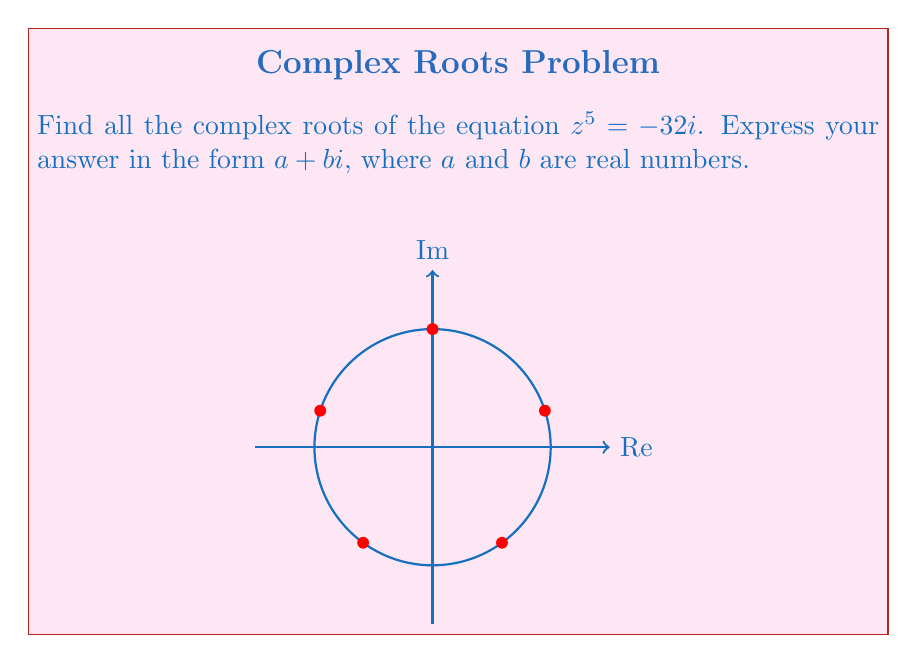Show me your answer to this math problem. Let's solve this step-by-step using De Moivre's theorem:

1) First, we need to express $-32i$ in polar form:
   $-32i = 32(\cos(\frac{3\pi}{2}) + i\sin(\frac{3\pi}{2}))$

2) Now, we can write the equation as:
   $z^5 = 32(\cos(\frac{3\pi}{2}) + i\sin(\frac{3\pi}{2}))$

3) Using De Moivre's theorem, we can write the general solution as:
   $z = 2(\cos(\frac{3\pi + 4k\pi}{10}) + i\sin(\frac{3\pi + 4k\pi}{10}))$
   where $k = 0, 1, 2, 3, 4$

4) Now, let's calculate each root:

   For $k = 0$:
   $z_1 = 2(\cos(\frac{3\pi}{10}) + i\sin(\frac{3\pi}{10}))$
   $= 2(\cos(54°) + i\sin(54°))$
   $\approx 1.18 + 1.62i$

   For $k = 1$:
   $z_2 = 2(\cos(\frac{7\pi}{10}) + i\sin(\frac{7\pi}{10}))$
   $= 2(\cos(126°) + i\sin(126°))$
   $\approx -1.18 + 1.62i$

   For $k = 2$:
   $z_3 = 2(\cos(\frac{11\pi}{10}) + i\sin(\frac{11\pi}{10}))$
   $= 2(\cos(198°) + i\sin(198°))$
   $\approx -1.90 - 0.62i$

   For $k = 3$:
   $z_4 = 2(\cos(\frac{15\pi}{10}) + i\sin(\frac{15\pi}{10}))$
   $= 2(\cos(270°) + i\sin(270°))$
   $= -2i$

   For $k = 4$:
   $z_5 = 2(\cos(\frac{19\pi}{10}) + i\sin(\frac{19\pi}{10}))$
   $= 2(\cos(342°) + i\sin(342°))$
   $\approx 1.90 - 0.62i$
Answer: $z_1 \approx 1.18 + 1.62i$, $z_2 \approx -1.18 + 1.62i$, $z_3 \approx -1.90 - 0.62i$, $z_4 = -2i$, $z_5 \approx 1.90 - 0.62i$ 